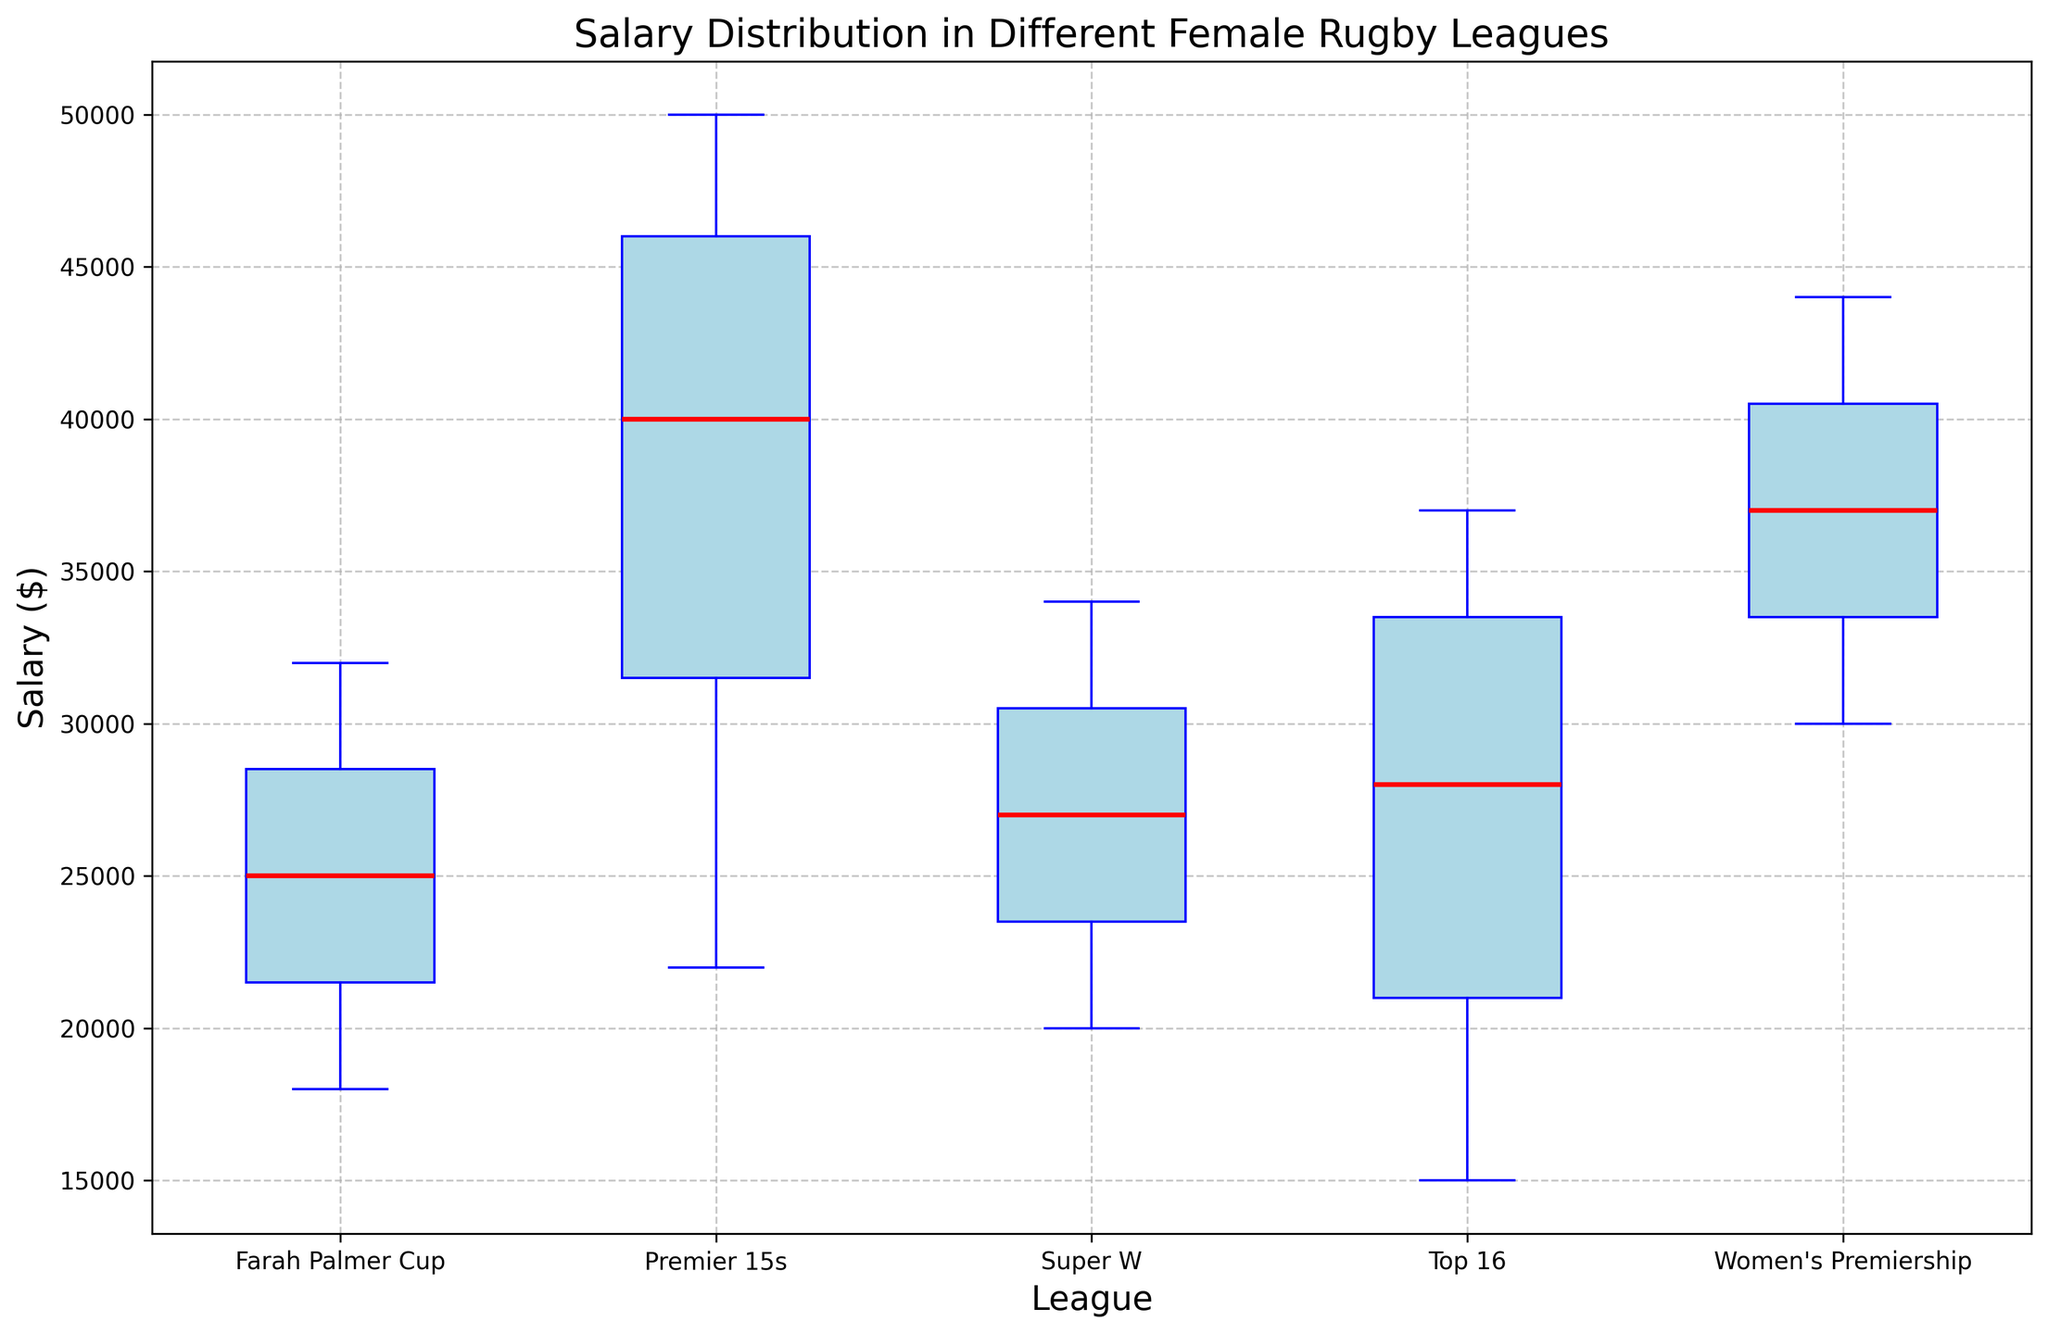What is the median salary in the Premier 15s league? Locate the central red line inside the box of the Premier 15s league. This line represents the median salary.
Answer: 40,000 Which league has the highest median salary, and what is it? Compare the central red lines of the boxes from each league. The Premier 15s league has the highest line, indicating the highest median salary.
Answer: Premier 15s, 40,000 How does the salary range (interquartile range) of the Farah Palmer Cup compare to the Women's Premiership? The salary range can be found by looking at the height of the box in each league. Measure the distance between the bottom and top edges of the boxes. The box of the Women's Premiership is taller than that of the Farah Palmer Cup, indicating a wider salary range.
Answer: Women's Premiership has a wider range Which league has the smallest range of salaries? Observe which box is the shortest in height. This indicates the smallest salary range for a league.
Answer: Super W Compare the maximum salary in the Premier 15s league with the maximum salary in the Top 16 league. Identify the top whisker or top edge of the box for each league. The Premier 15s league has a higher max salary whisker.
Answer: Premier 15s has a higher max What is the difference between the median salary of the Super W league and the Farah Palmer Cup? Find the median lines (red lines) for both leagues and subtract the median of the Farah Palmer Cup from the median of the Super W.
Answer: 2,000 What league exhibits the largest variance in salaries? Look for the league with both the largest interquartile range (distance of the box) and the largest whiskers (lines extending from the box).
Answer: Premier 15s Are there any outliers in the salary distributions? Typically, outliers would be represented by points lying outside the whiskers. In this figure, there are no data points outside the whiskers for any league.
Answer: No Which leagues have a median salary of at least 30,000? Check the median (red line) for each league, and see which ones are at or above the 30,000 mark.
Answer: Premier 15s, Women's Premiership, Super W Which league has the most concentrated salary distribution? The salary distribution concentration can be inferred from the narrowest box and shortest whiskers. Look for the most compact box and whiskers.
Answer: Super W 